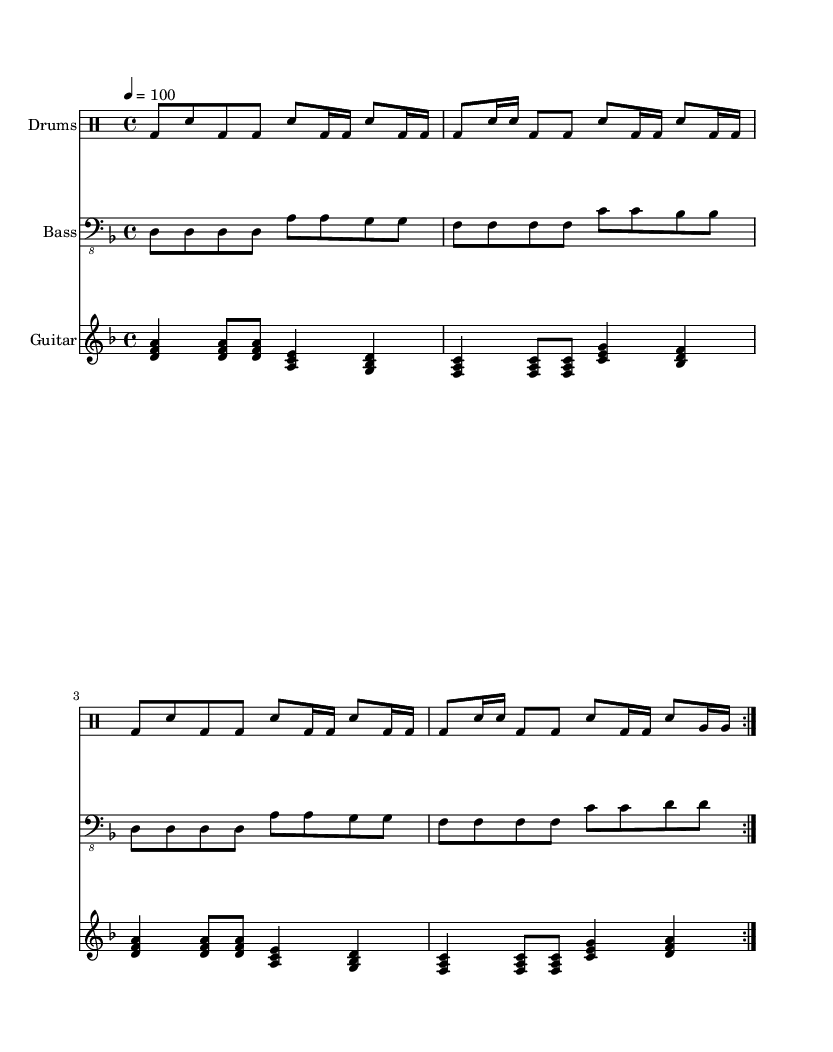What is the key signature of this music? The key signature is indicated by the sharps or flats at the beginning of the staff. In this case, there are no sharps or flats, which means it is in the key of D minor.
Answer: D minor What is the time signature of this music? The time signature is located at the beginning of the sheet music, indicating how many beats are in each measure. Here, it shows 4/4, which means there are four beats in each measure.
Answer: 4/4 What is the tempo marking for this piece? The tempo marking is typically given at the beginning of the piece to indicate speed. Here, it shows a tempo of quarter note equals 100 beats per minute.
Answer: 100 How many measures are repeated in the main groove? The repetition indication, "volta", suggests that the section is played twice. Counting the measures within that section shows four measures are repeated.
Answer: 4 What is the predominant drum pattern used throughout? By analyzing the drum part, it's evident the pattern consists primarily of bass drum and snare interactions, creating a hip-hop-inspired rhythm that emphasizes a groove-heavy style, typical of nu metal.
Answer: Bass and snare groove What type of guitar voicing is used in the progression? The guitar part consists of triads, specifically major chords accompanied by specific rhythmic patterns typical in metal music, which enhances the aggressive sound of the overall piece.
Answer: Triads What is the highest note played in the bass part? Looking closely at the bass part, the highest note within the given measures is the A note, appearing in the fourth octave range of the staff.
Answer: A 